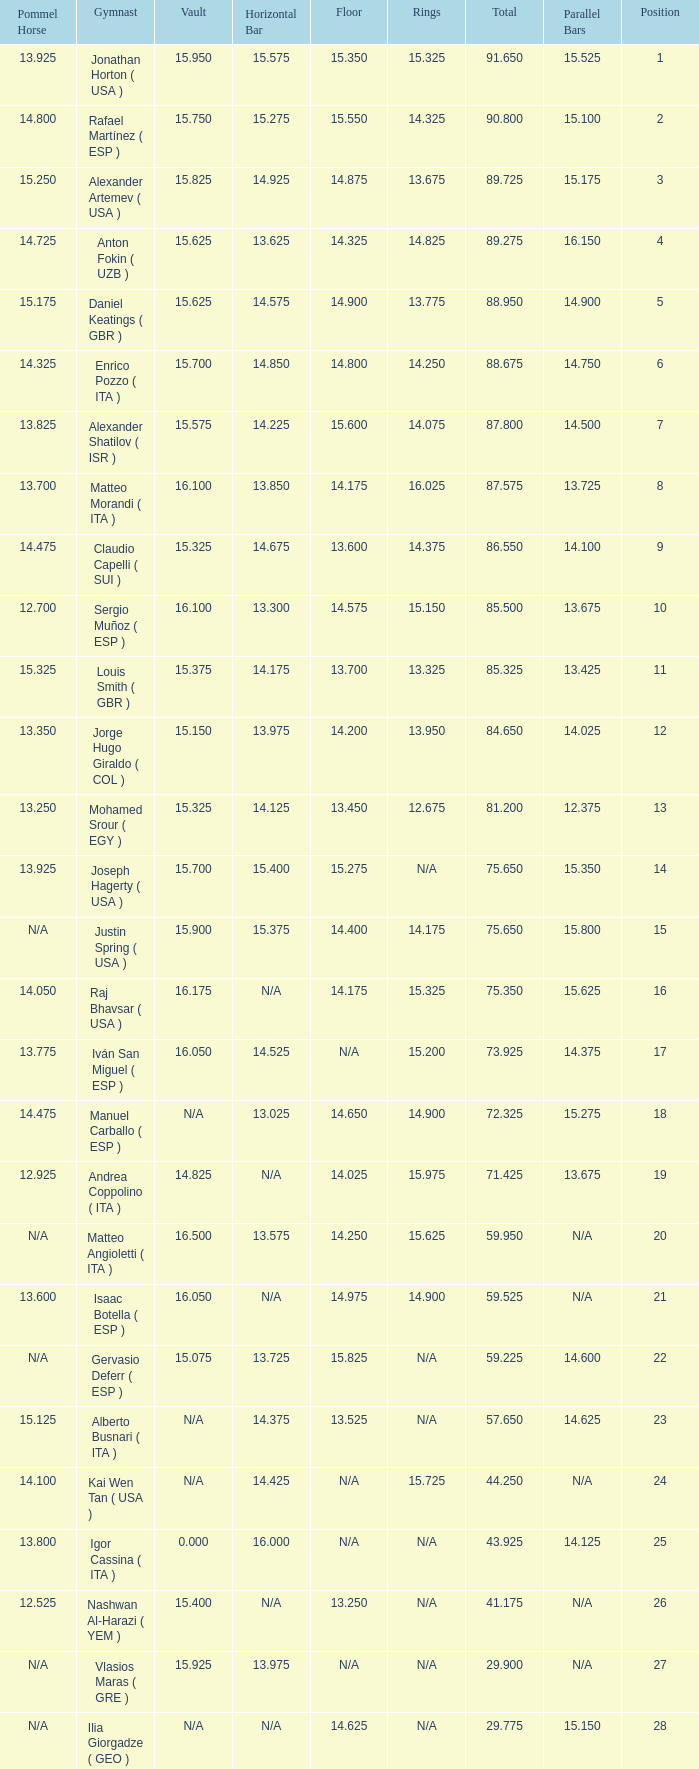If the parallel bars is 14.025, what is the total number of gymnasts? 1.0. 